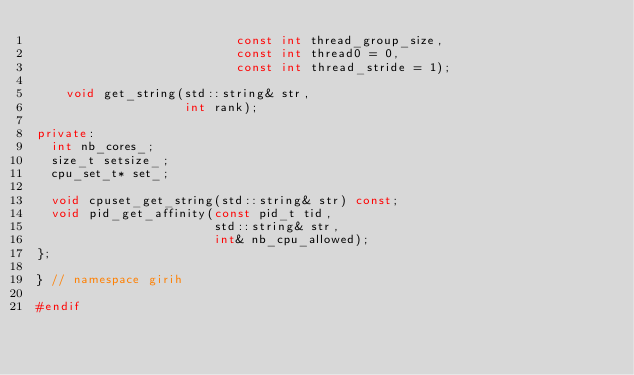Convert code to text. <code><loc_0><loc_0><loc_500><loc_500><_C++_>                           const int thread_group_size,
                           const int thread0 = 0,
                           const int thread_stride = 1);

    void get_string(std::string& str,
                    int rank);

private:
  int nb_cores_;
  size_t setsize_;
  cpu_set_t* set_;

  void cpuset_get_string(std::string& str) const;
  void pid_get_affinity(const pid_t tid,
                        std::string& str,
                        int& nb_cpu_allowed);
};

} // namespace girih

#endif</code> 